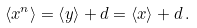Convert formula to latex. <formula><loc_0><loc_0><loc_500><loc_500>\left < x ^ { n } \right > = \left < y \right > + d = \left < x \right > + d \, .</formula> 